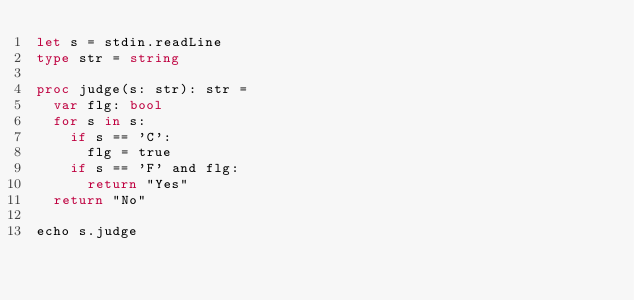<code> <loc_0><loc_0><loc_500><loc_500><_Nim_>let s = stdin.readLine
type str = string

proc judge(s: str): str =
  var flg: bool
  for s in s:
    if s == 'C':
      flg = true
    if s == 'F' and flg:
      return "Yes"
  return "No"

echo s.judge
</code> 